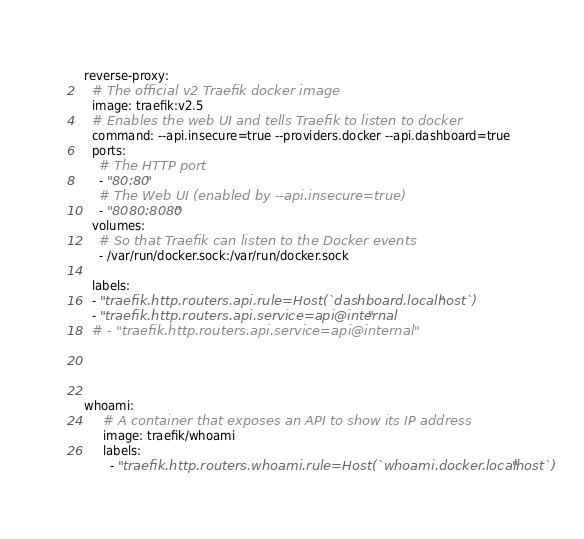<code> <loc_0><loc_0><loc_500><loc_500><_YAML_>  reverse-proxy:
    # The official v2 Traefik docker image
    image: traefik:v2.5
    # Enables the web UI and tells Traefik to listen to docker
    command: --api.insecure=true --providers.docker --api.dashboard=true
    ports:
      # The HTTP port
      - "80:80"
      # The Web UI (enabled by --api.insecure=true)
      - "8080:8080"
    volumes:
      # So that Traefik can listen to the Docker events
      - /var/run/docker.sock:/var/run/docker.sock
      
    labels:
    - "traefik.http.routers.api.rule=Host(`dashboard.localhost`)"
    - "traefik.http.routers.api.service=api@internal"
    # - "traefik.http.routers.api.service=api@internal"
    
    
      
      
  whoami:
       # A container that exposes an API to show its IP address
       image: traefik/whoami
       labels:
         - "traefik.http.routers.whoami.rule=Host(`whoami.docker.localhost`)"</code> 